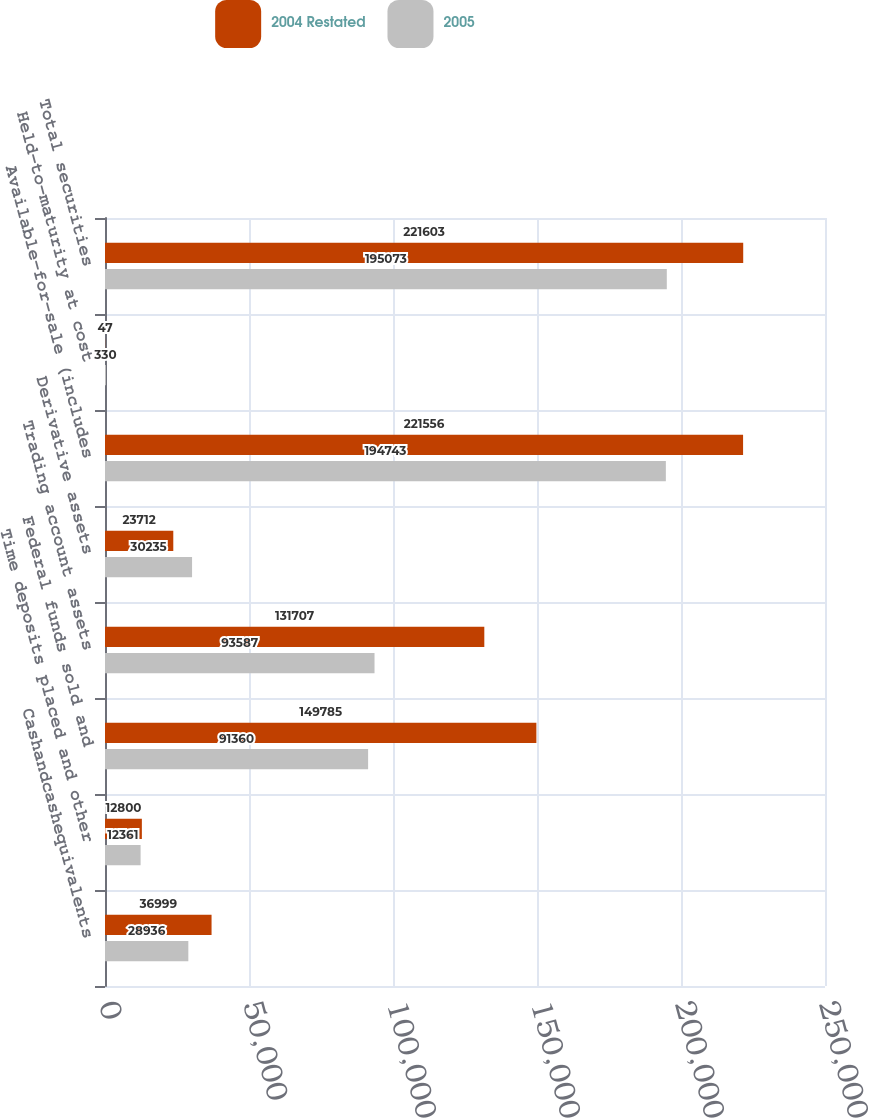Convert chart to OTSL. <chart><loc_0><loc_0><loc_500><loc_500><stacked_bar_chart><ecel><fcel>Cashandcashequivalents<fcel>Time deposits placed and other<fcel>Federal funds sold and<fcel>Trading account assets<fcel>Derivative assets<fcel>Available-for-sale (includes<fcel>Held-to-maturity at cost<fcel>Total securities<nl><fcel>2004 Restated<fcel>36999<fcel>12800<fcel>149785<fcel>131707<fcel>23712<fcel>221556<fcel>47<fcel>221603<nl><fcel>2005<fcel>28936<fcel>12361<fcel>91360<fcel>93587<fcel>30235<fcel>194743<fcel>330<fcel>195073<nl></chart> 